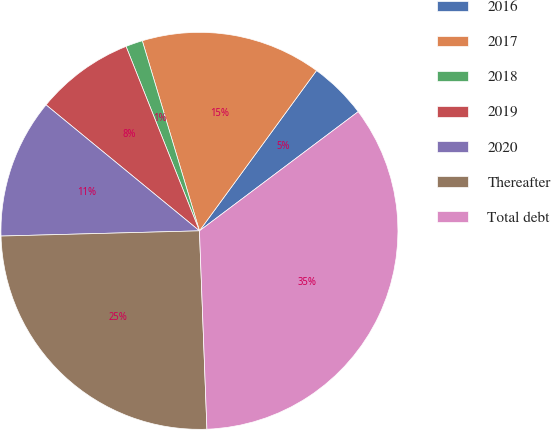Convert chart. <chart><loc_0><loc_0><loc_500><loc_500><pie_chart><fcel>2016<fcel>2017<fcel>2018<fcel>2019<fcel>2020<fcel>Thereafter<fcel>Total debt<nl><fcel>4.71%<fcel>14.69%<fcel>1.38%<fcel>8.03%<fcel>11.36%<fcel>25.18%<fcel>34.65%<nl></chart> 